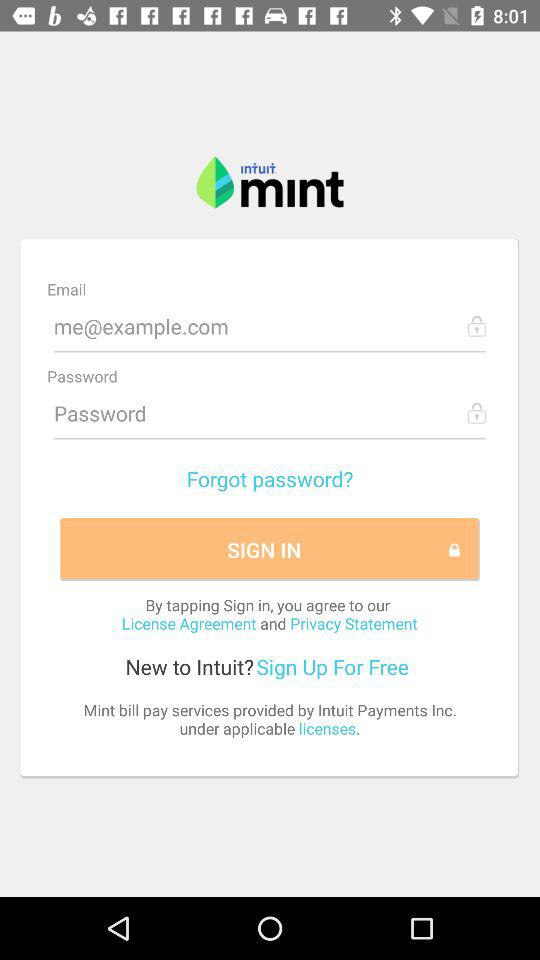How many text fields are there in this screenshot?
Answer the question using a single word or phrase. 2 